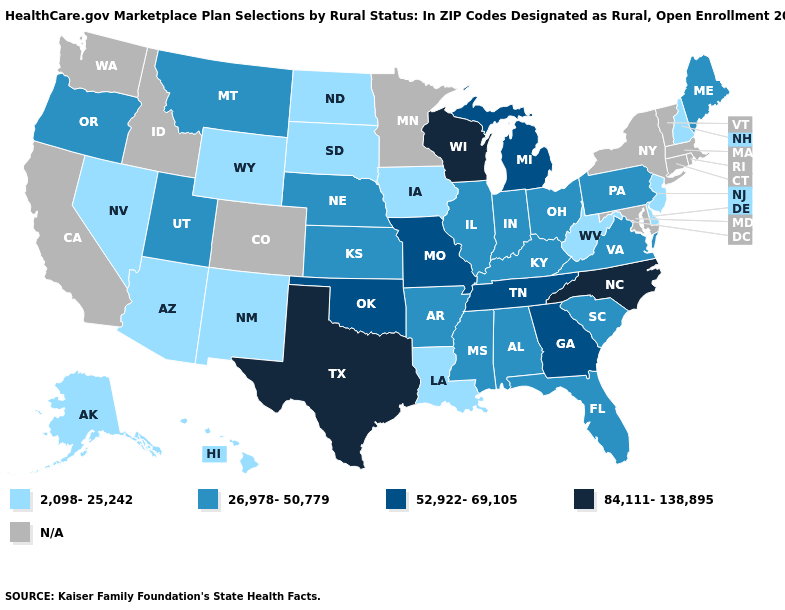What is the value of Kentucky?
Answer briefly. 26,978-50,779. What is the value of Mississippi?
Answer briefly. 26,978-50,779. Name the states that have a value in the range 52,922-69,105?
Give a very brief answer. Georgia, Michigan, Missouri, Oklahoma, Tennessee. Name the states that have a value in the range 2,098-25,242?
Quick response, please. Alaska, Arizona, Delaware, Hawaii, Iowa, Louisiana, Nevada, New Hampshire, New Jersey, New Mexico, North Dakota, South Dakota, West Virginia, Wyoming. What is the lowest value in states that border Nebraska?
Give a very brief answer. 2,098-25,242. What is the lowest value in states that border Illinois?
Give a very brief answer. 2,098-25,242. Does the map have missing data?
Concise answer only. Yes. Among the states that border Tennessee , does Arkansas have the highest value?
Give a very brief answer. No. Name the states that have a value in the range N/A?
Quick response, please. California, Colorado, Connecticut, Idaho, Maryland, Massachusetts, Minnesota, New York, Rhode Island, Vermont, Washington. What is the lowest value in states that border Vermont?
Short answer required. 2,098-25,242. Which states have the lowest value in the USA?
Short answer required. Alaska, Arizona, Delaware, Hawaii, Iowa, Louisiana, Nevada, New Hampshire, New Jersey, New Mexico, North Dakota, South Dakota, West Virginia, Wyoming. Does North Dakota have the highest value in the MidWest?
Quick response, please. No. What is the highest value in states that border Arizona?
Short answer required. 26,978-50,779. What is the highest value in states that border New Mexico?
Give a very brief answer. 84,111-138,895. Name the states that have a value in the range 52,922-69,105?
Answer briefly. Georgia, Michigan, Missouri, Oklahoma, Tennessee. 